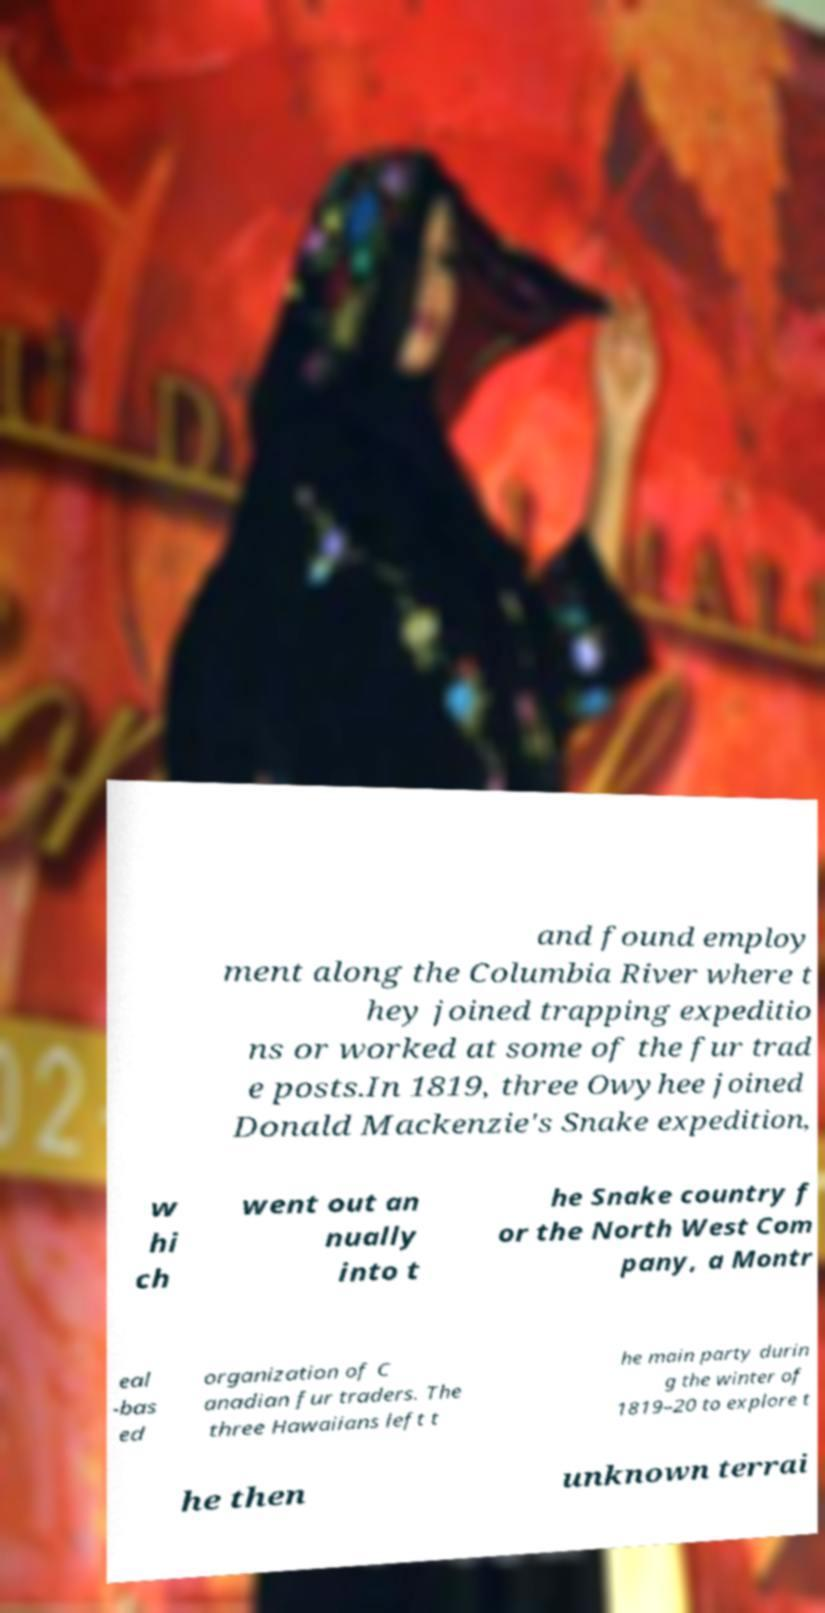For documentation purposes, I need the text within this image transcribed. Could you provide that? and found employ ment along the Columbia River where t hey joined trapping expeditio ns or worked at some of the fur trad e posts.In 1819, three Owyhee joined Donald Mackenzie's Snake expedition, w hi ch went out an nually into t he Snake country f or the North West Com pany, a Montr eal -bas ed organization of C anadian fur traders. The three Hawaiians left t he main party durin g the winter of 1819–20 to explore t he then unknown terrai 